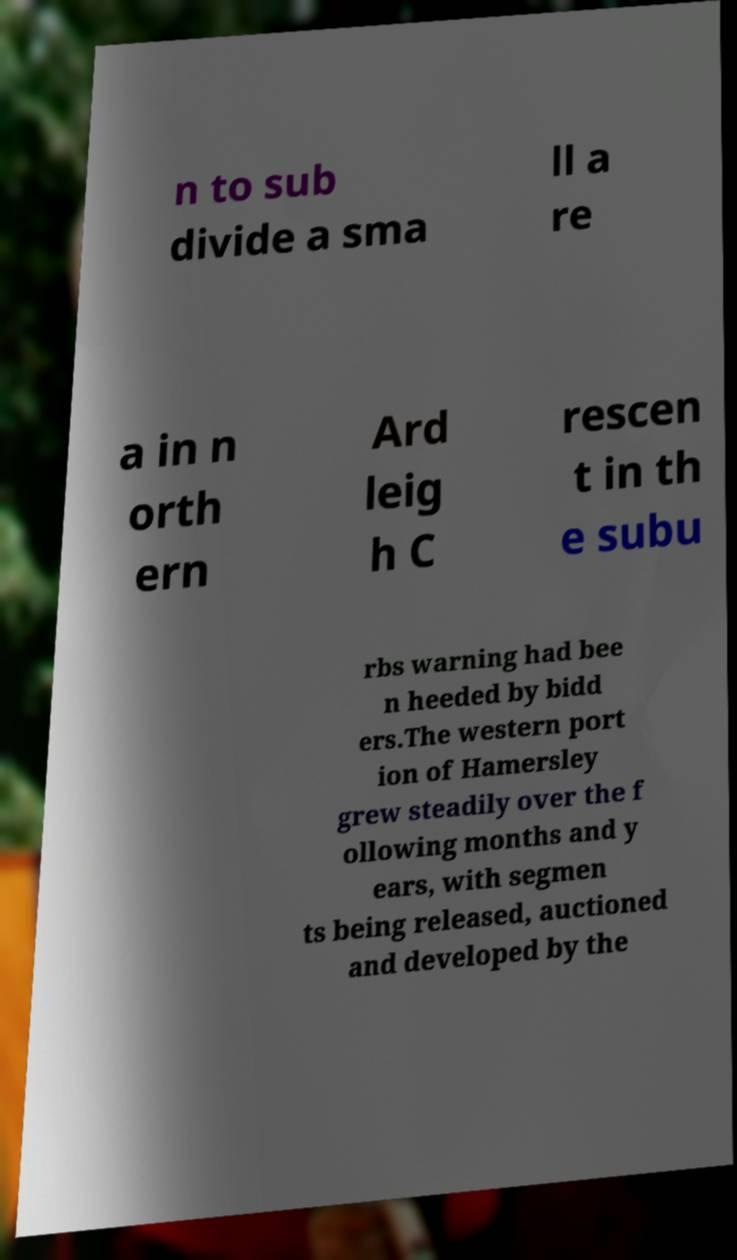Can you read and provide the text displayed in the image?This photo seems to have some interesting text. Can you extract and type it out for me? n to sub divide a sma ll a re a in n orth ern Ard leig h C rescen t in th e subu rbs warning had bee n heeded by bidd ers.The western port ion of Hamersley grew steadily over the f ollowing months and y ears, with segmen ts being released, auctioned and developed by the 